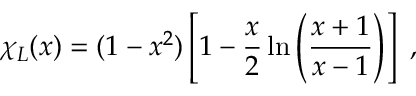<formula> <loc_0><loc_0><loc_500><loc_500>\chi _ { L } ( x ) = ( 1 - x ^ { 2 } ) \left [ 1 - \frac { x } { 2 } \ln \left ( \frac { x + 1 } { x - 1 } \right ) \right ] \ ,</formula> 